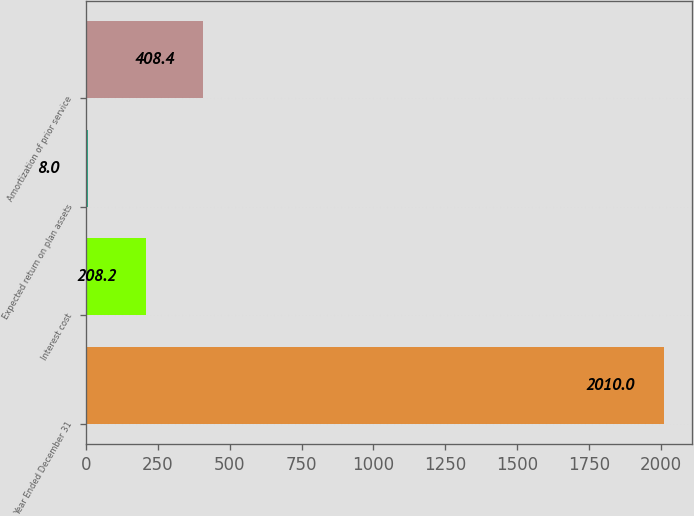Convert chart to OTSL. <chart><loc_0><loc_0><loc_500><loc_500><bar_chart><fcel>Year Ended December 31<fcel>Interest cost<fcel>Expected return on plan assets<fcel>Amortization of prior service<nl><fcel>2010<fcel>208.2<fcel>8<fcel>408.4<nl></chart> 